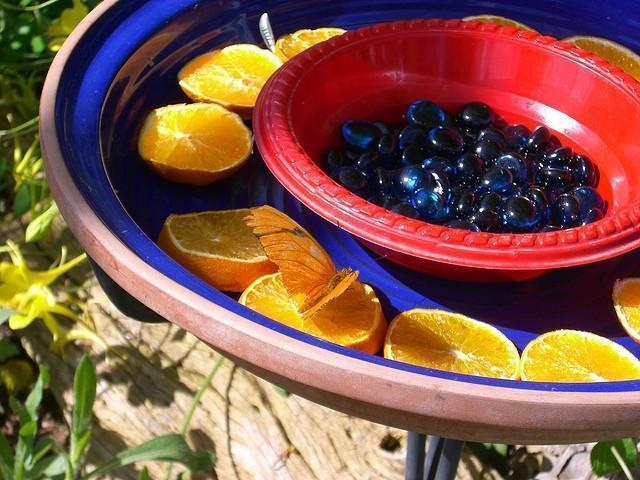What food group is being served?
Choose the correct response and explain in the format: 'Answer: answer
Rationale: rationale.'
Options: Vegetables, meat, dairy, fruits. Answer: fruits.
Rationale: The food is a fruit. 